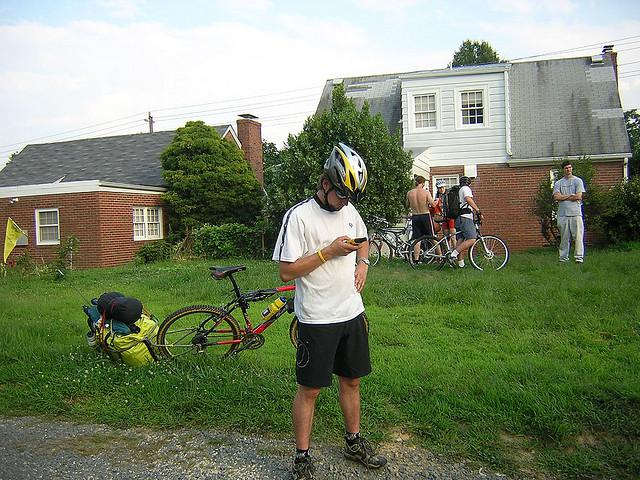Why is the man looking down at his hand?

Choices:
A) holding cash
B) see cut
C) answering phone
D) to eat answering phone 